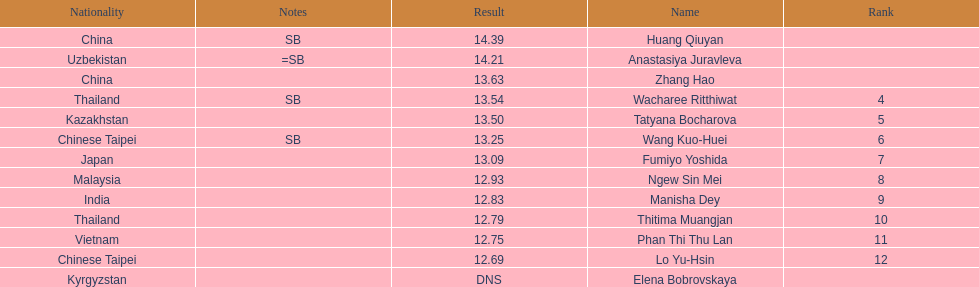What is the difference between huang qiuyan's result and fumiyo yoshida's result? 1.3. Can you give me this table as a dict? {'header': ['Nationality', 'Notes', 'Result', 'Name', 'Rank'], 'rows': [['China', 'SB', '14.39', 'Huang Qiuyan', ''], ['Uzbekistan', '=SB', '14.21', 'Anastasiya Juravleva', ''], ['China', '', '13.63', 'Zhang Hao', ''], ['Thailand', 'SB', '13.54', 'Wacharee Ritthiwat', '4'], ['Kazakhstan', '', '13.50', 'Tatyana Bocharova', '5'], ['Chinese Taipei', 'SB', '13.25', 'Wang Kuo-Huei', '6'], ['Japan', '', '13.09', 'Fumiyo Yoshida', '7'], ['Malaysia', '', '12.93', 'Ngew Sin Mei', '8'], ['India', '', '12.83', 'Manisha Dey', '9'], ['Thailand', '', '12.79', 'Thitima Muangjan', '10'], ['Vietnam', '', '12.75', 'Phan Thi Thu Lan', '11'], ['Chinese Taipei', '', '12.69', 'Lo Yu-Hsin', '12'], ['Kyrgyzstan', '', 'DNS', 'Elena Bobrovskaya', '']]} 